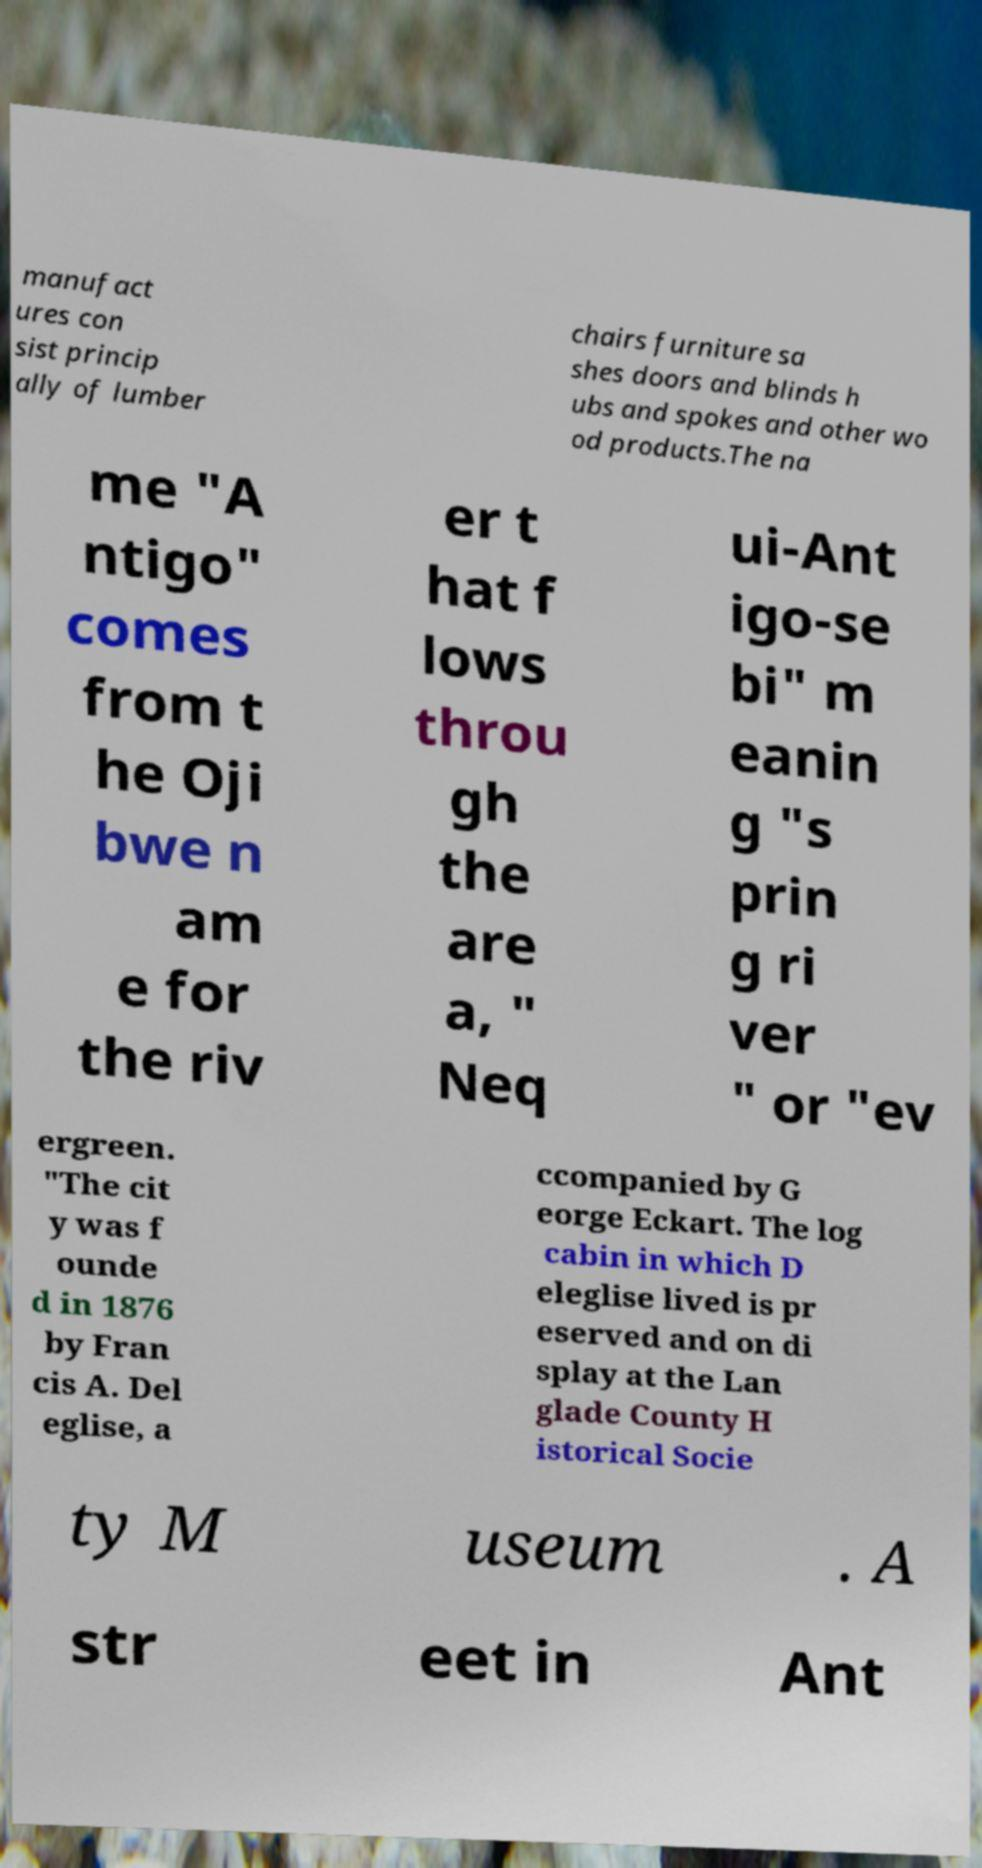For documentation purposes, I need the text within this image transcribed. Could you provide that? manufact ures con sist princip ally of lumber chairs furniture sa shes doors and blinds h ubs and spokes and other wo od products.The na me "A ntigo" comes from t he Oji bwe n am e for the riv er t hat f lows throu gh the are a, " Neq ui-Ant igo-se bi" m eanin g "s prin g ri ver " or "ev ergreen. "The cit y was f ounde d in 1876 by Fran cis A. Del eglise, a ccompanied by G eorge Eckart. The log cabin in which D eleglise lived is pr eserved and on di splay at the Lan glade County H istorical Socie ty M useum . A str eet in Ant 